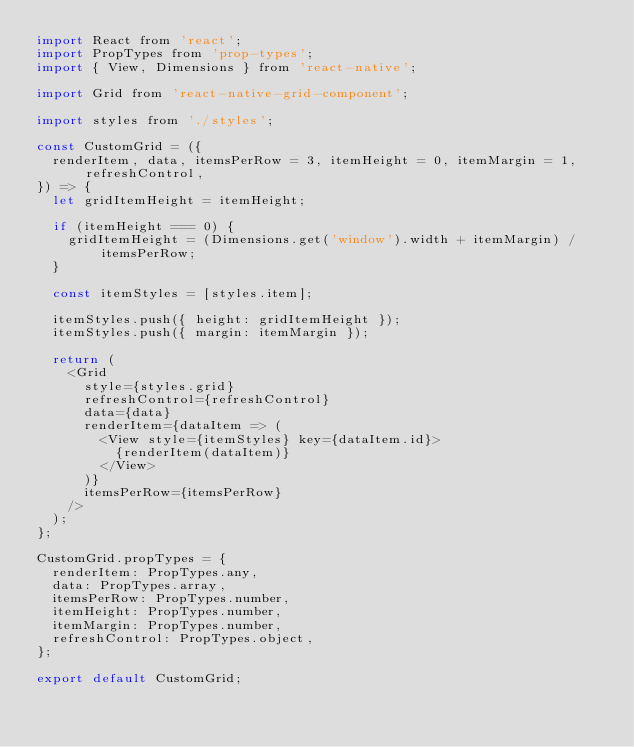Convert code to text. <code><loc_0><loc_0><loc_500><loc_500><_JavaScript_>import React from 'react';
import PropTypes from 'prop-types';
import { View, Dimensions } from 'react-native';

import Grid from 'react-native-grid-component';

import styles from './styles';

const CustomGrid = ({
  renderItem, data, itemsPerRow = 3, itemHeight = 0, itemMargin = 1, refreshControl,
}) => {
  let gridItemHeight = itemHeight;

  if (itemHeight === 0) {
    gridItemHeight = (Dimensions.get('window').width + itemMargin) / itemsPerRow;
  }

  const itemStyles = [styles.item];

  itemStyles.push({ height: gridItemHeight });
  itemStyles.push({ margin: itemMargin });

  return (
    <Grid
      style={styles.grid}
      refreshControl={refreshControl}
      data={data}
      renderItem={dataItem => (
        <View style={itemStyles} key={dataItem.id}>
          {renderItem(dataItem)}
        </View>
      )}
      itemsPerRow={itemsPerRow}
    />
  );
};

CustomGrid.propTypes = {
  renderItem: PropTypes.any,
  data: PropTypes.array,
  itemsPerRow: PropTypes.number,
  itemHeight: PropTypes.number,
  itemMargin: PropTypes.number,
  refreshControl: PropTypes.object,
};

export default CustomGrid;
</code> 